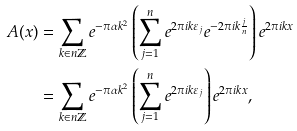Convert formula to latex. <formula><loc_0><loc_0><loc_500><loc_500>A ( x ) & = \sum _ { k \in n \mathbb { Z } } e ^ { - \pi \alpha k ^ { 2 } } \left ( \sum _ { j = 1 } ^ { n } e ^ { 2 \pi i k \varepsilon _ { j } } e ^ { - 2 \pi i k \frac { j } { n } } \right ) e ^ { 2 \pi i k x } \\ & = \sum _ { k \in n \mathbb { Z } } e ^ { - \pi \alpha k ^ { 2 } } \left ( \sum _ { j = 1 } ^ { n } e ^ { 2 \pi i k \varepsilon _ { j } } \right ) e ^ { 2 \pi i k x } ,</formula> 